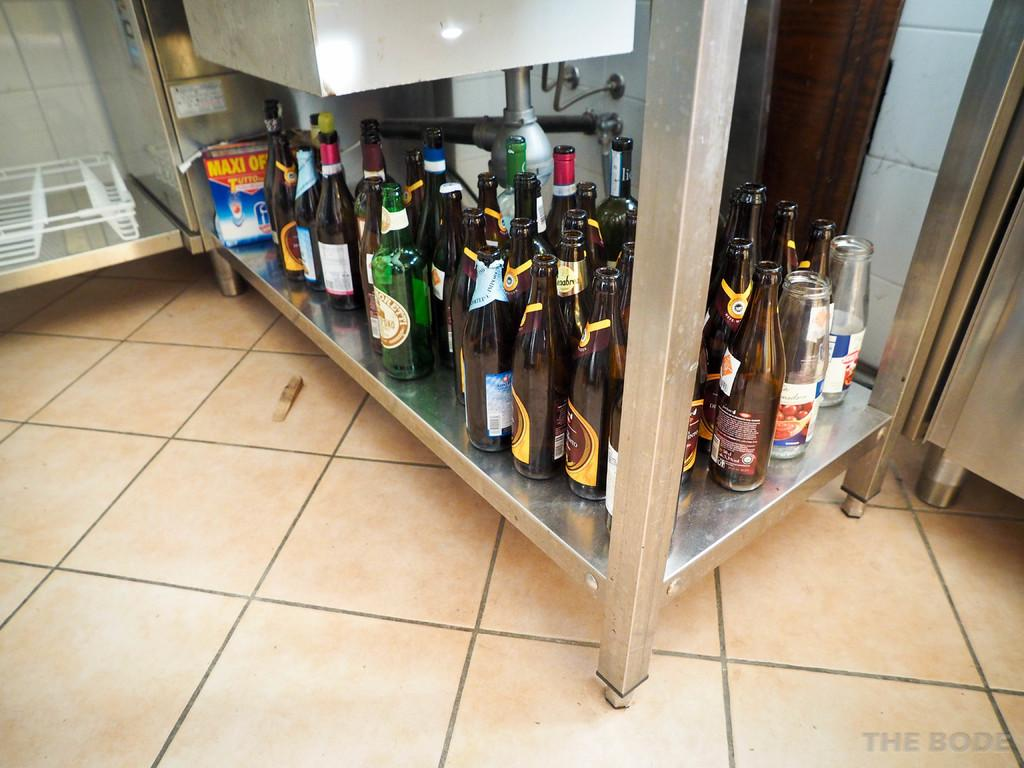What objects can be seen in the image? There are bottles in the image. Where are the bottles placed? The bottles are placed on an iron table. What can be seen in the background of the image? Some wires, cylinders, and a tray are visible in the background. What is the surface visible beneath the objects in the image? The floor is visible in the image. Who is the owner of the wound visible in the image? There is no wound visible in the image. 